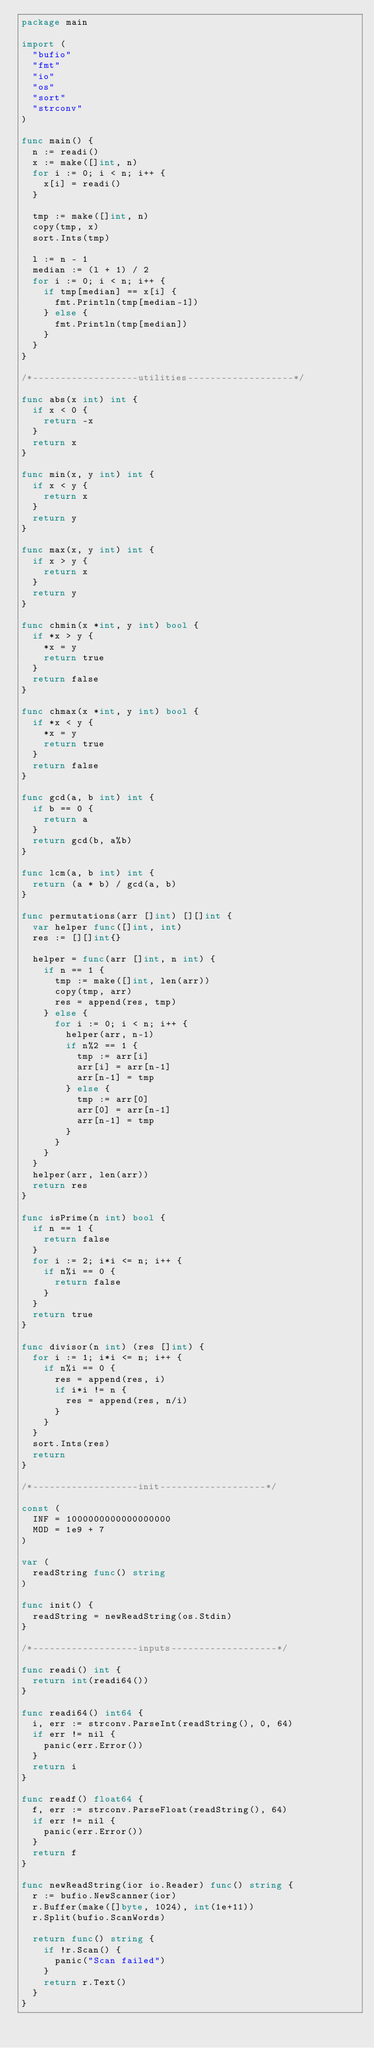Convert code to text. <code><loc_0><loc_0><loc_500><loc_500><_Go_>package main

import (
	"bufio"
	"fmt"
	"io"
	"os"
	"sort"
	"strconv"
)

func main() {
	n := readi()
	x := make([]int, n)
	for i := 0; i < n; i++ {
		x[i] = readi()
	}

	tmp := make([]int, n)
	copy(tmp, x)
	sort.Ints(tmp)

	l := n - 1
	median := (l + 1) / 2
	for i := 0; i < n; i++ {
		if tmp[median] == x[i] {
			fmt.Println(tmp[median-1])
		} else {
			fmt.Println(tmp[median])
		}
	}
}

/*-------------------utilities-------------------*/

func abs(x int) int {
	if x < 0 {
		return -x
	}
	return x
}

func min(x, y int) int {
	if x < y {
		return x
	}
	return y
}

func max(x, y int) int {
	if x > y {
		return x
	}
	return y
}

func chmin(x *int, y int) bool {
	if *x > y {
		*x = y
		return true
	}
	return false
}

func chmax(x *int, y int) bool {
	if *x < y {
		*x = y
		return true
	}
	return false
}

func gcd(a, b int) int {
	if b == 0 {
		return a
	}
	return gcd(b, a%b)
}

func lcm(a, b int) int {
	return (a * b) / gcd(a, b)
}

func permutations(arr []int) [][]int {
	var helper func([]int, int)
	res := [][]int{}

	helper = func(arr []int, n int) {
		if n == 1 {
			tmp := make([]int, len(arr))
			copy(tmp, arr)
			res = append(res, tmp)
		} else {
			for i := 0; i < n; i++ {
				helper(arr, n-1)
				if n%2 == 1 {
					tmp := arr[i]
					arr[i] = arr[n-1]
					arr[n-1] = tmp
				} else {
					tmp := arr[0]
					arr[0] = arr[n-1]
					arr[n-1] = tmp
				}
			}
		}
	}
	helper(arr, len(arr))
	return res
}

func isPrime(n int) bool {
	if n == 1 {
		return false
	}
	for i := 2; i*i <= n; i++ {
		if n%i == 0 {
			return false
		}
	}
	return true
}

func divisor(n int) (res []int) {
	for i := 1; i*i <= n; i++ {
		if n%i == 0 {
			res = append(res, i)
			if i*i != n {
				res = append(res, n/i)
			}
		}
	}
	sort.Ints(res)
	return
}

/*-------------------init-------------------*/

const (
	INF = 1000000000000000000
	MOD = 1e9 + 7
)

var (
	readString func() string
)

func init() {
	readString = newReadString(os.Stdin)
}

/*-------------------inputs-------------------*/

func readi() int {
	return int(readi64())
}

func readi64() int64 {
	i, err := strconv.ParseInt(readString(), 0, 64)
	if err != nil {
		panic(err.Error())
	}
	return i
}

func readf() float64 {
	f, err := strconv.ParseFloat(readString(), 64)
	if err != nil {
		panic(err.Error())
	}
	return f
}

func newReadString(ior io.Reader) func() string {
	r := bufio.NewScanner(ior)
	r.Buffer(make([]byte, 1024), int(1e+11))
	r.Split(bufio.ScanWords)

	return func() string {
		if !r.Scan() {
			panic("Scan failed")
		}
		return r.Text()
	}
}
</code> 